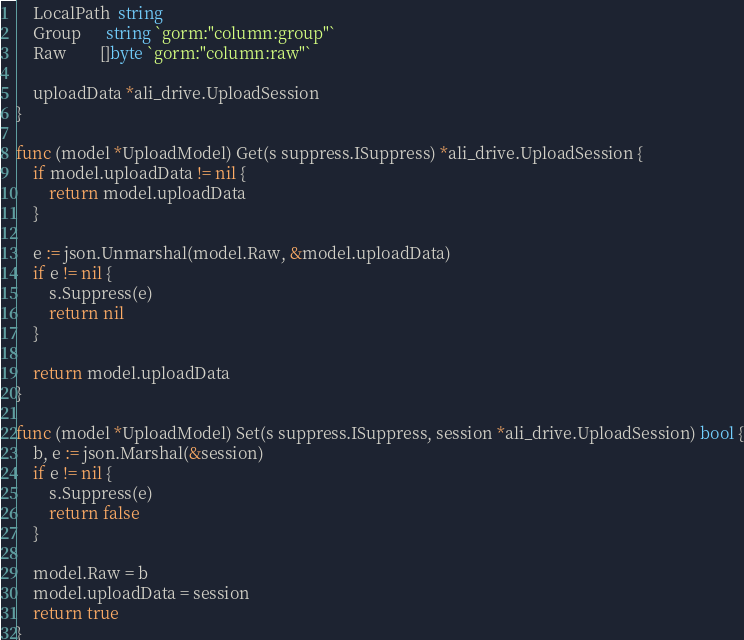Convert code to text. <code><loc_0><loc_0><loc_500><loc_500><_Go_>	LocalPath  string
	Group      string `gorm:"column:group"`
	Raw        []byte `gorm:"column:raw"`

	uploadData *ali_drive.UploadSession
}

func (model *UploadModel) Get(s suppress.ISuppress) *ali_drive.UploadSession {
	if model.uploadData != nil {
		return model.uploadData
	}

	e := json.Unmarshal(model.Raw, &model.uploadData)
	if e != nil {
		s.Suppress(e)
		return nil
	}

	return model.uploadData
}

func (model *UploadModel) Set(s suppress.ISuppress, session *ali_drive.UploadSession) bool {
	b, e := json.Marshal(&session)
	if e != nil {
		s.Suppress(e)
		return false
	}

	model.Raw = b
	model.uploadData = session
	return true
}
</code> 